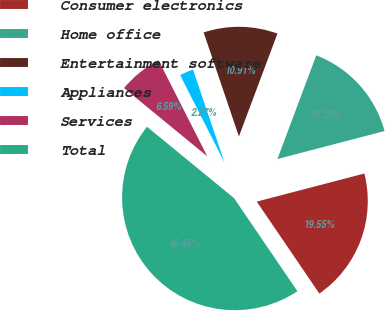<chart> <loc_0><loc_0><loc_500><loc_500><pie_chart><fcel>Consumer electronics<fcel>Home office<fcel>Entertainment software<fcel>Appliances<fcel>Services<fcel>Total<nl><fcel>19.55%<fcel>15.23%<fcel>10.91%<fcel>2.27%<fcel>6.59%<fcel>45.45%<nl></chart> 